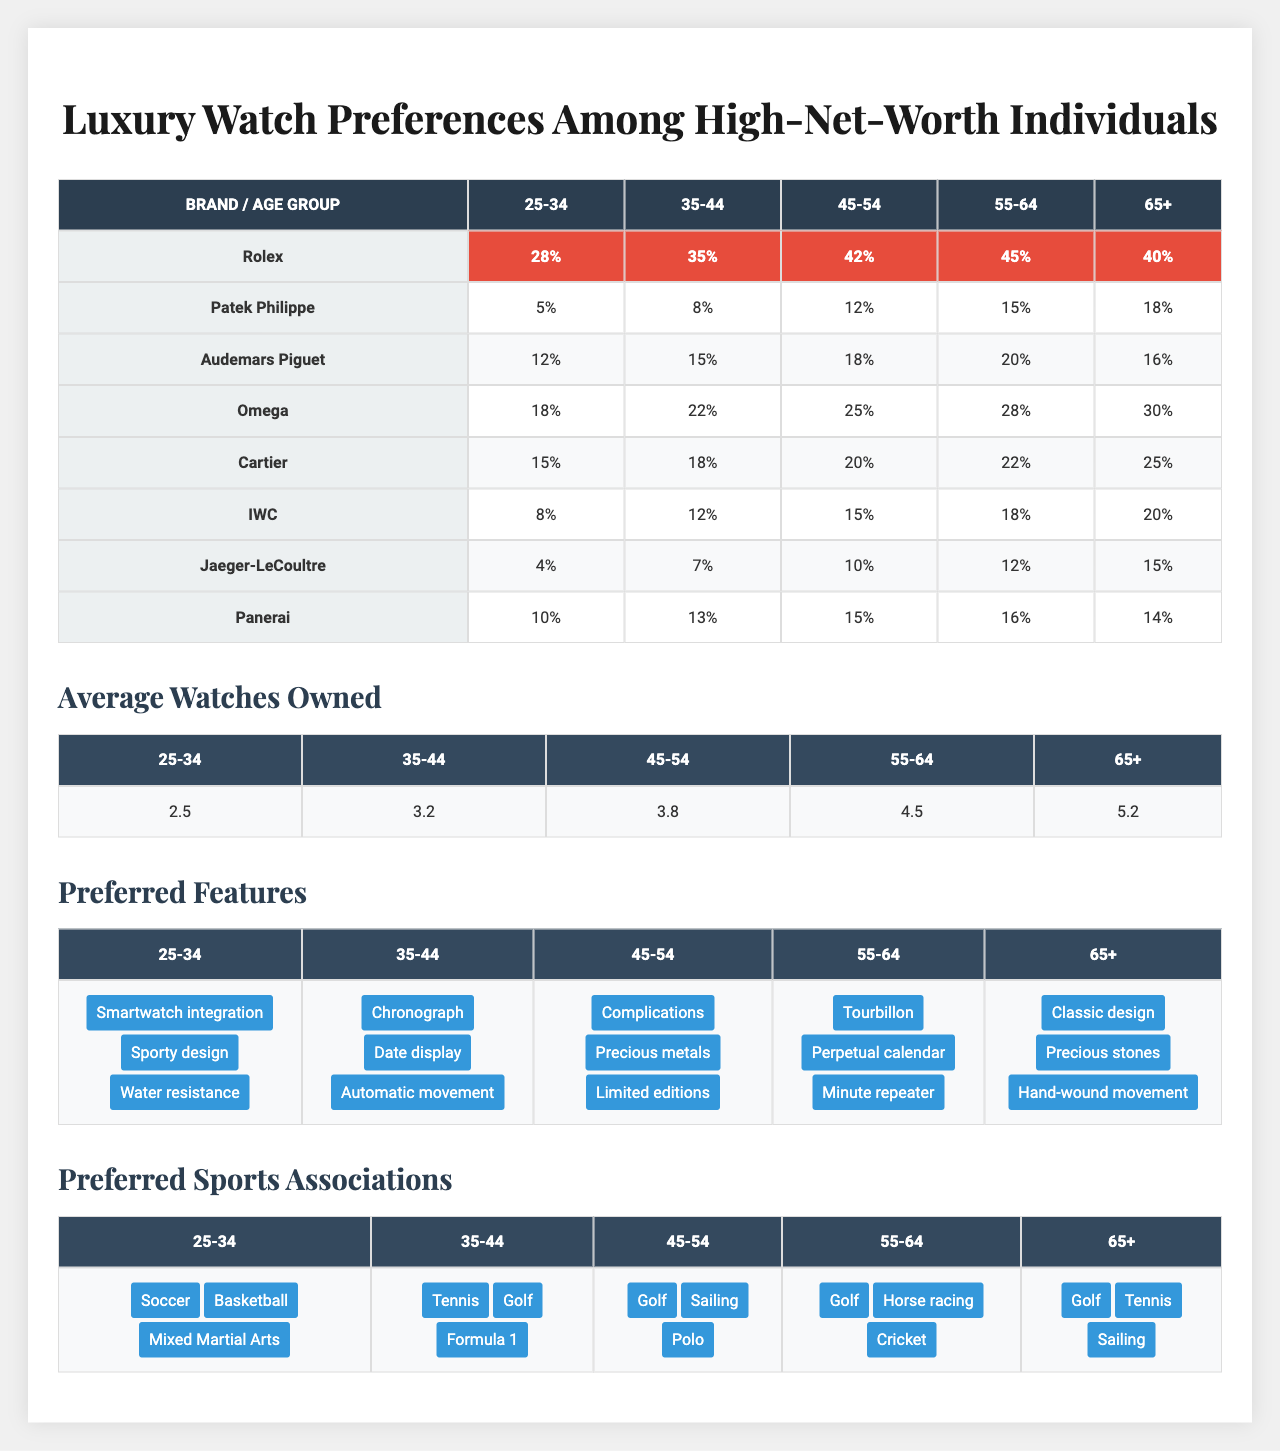What is the ownership percentage of Rolex among individuals aged 45-54? From the table, we can see that in the "Ownership Percentages" section, the percentage for Rolex within the 45-54 age group is 42%.
Answer: 42% Which age group has the highest average number of watches owned? By looking at the "Average Watches Owned" section of the table, the age group 65+ has the highest average at 5.2 watches.
Answer: 65+ How does the watch ownership percentage of Omega compare between the 35-44 and 45-54 age groups? The percentage for Omega in the 35-44 age group is 22%, while in the 45-54 age group, it is 25%. Comparing these shows that the ownership percentage of Omega is higher in the 45-54 age group by 3%.
Answer: 3% higher for 45-54 group Which features are preferred by individuals aged 55-64? In the "Preferred Features" section, individuals aged 55-64 prefer Tourbillon, Perpetual calendar, and Minute repeater.
Answer: Tourbillon, Perpetual calendar, and Minute repeater Is Audemars Piguet preferred more by individuals aged 35-44 or 65+? In the table, Audemars Piguet has an ownership percentage of 15% among the 35-44 age group and 16% in the 65+ age group. Since 16% is greater than 15%, Audemars Piguet is preferred more by the 65+ age group.
Answer: Yes, more preferred by the 65+ age group What is the total ownership percentage of luxury watches (Rolex, Patek Philippe, and Audemars Piguet) for individuals aged 25-34? To find the total ownership percentage for the 25-34 age group, we add the values: Rolex (28%) + Patek Philippe (5%) + Audemars Piguet (12%) = 45%.
Answer: 45% Among all age groups, which sport is the least preferred by individuals aged 65+? In the "Preferred Sports Associations" section, the sports preferred by the 65+ age group are Golf, Tennis, and Sailing. There is no indication of a least preferred sport as all three are listed equally without additional data. Since none stands out, the conclusion is there is no least preferred sport.
Answer: No least preferred sport identified Which age group prefers smart-watch integration features the most? Referring to the "Preferred Features" section, smart-watch integration is listed under the 25-34 age group, indicating this group shows the most preference for it.
Answer: 25-34 age group What is the difference in ownership percentage of Cartier watches between the 45-54 and 65+ age groups? From the table, Cartier has 20% ownership in the 45-54 age group and 25% in the 65+ age group. The difference is 25% - 20% = 5%.
Answer: 5% difference What is the percentage of Audemars Piguet ownership in the 55-64 age group? Looking at the "Ownership Percentages," Audemars Piguet has a 20% ownership in the 55-64 age group.
Answer: 20% Which brand shows the most significant increase in ownership percentage from the 35-44 age group to the 45-54 age group? By comparing the ownership percentages, Rolex increases from 35% to 42%, which is a 7% increase. Comparing other brands, Rolex shows the most significant increase.
Answer: Rolex, 7% increase 